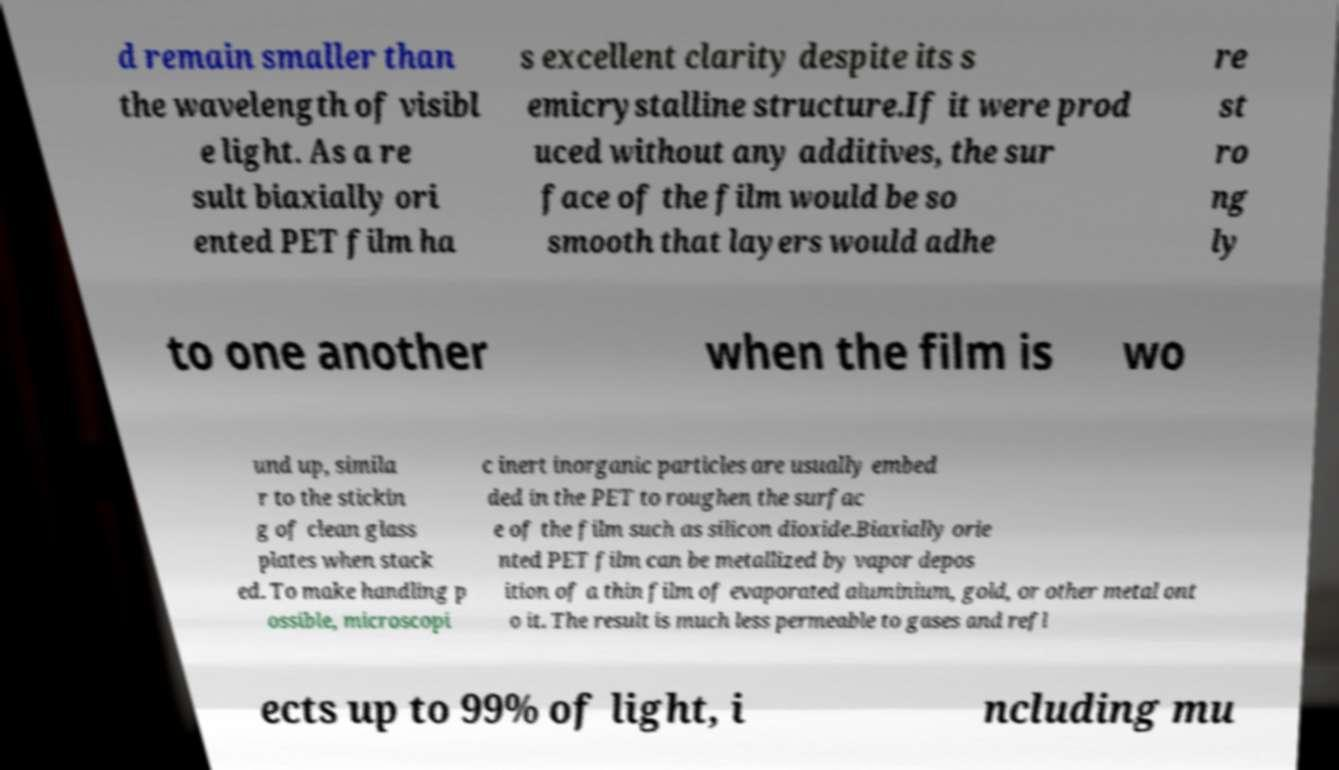Can you read and provide the text displayed in the image?This photo seems to have some interesting text. Can you extract and type it out for me? d remain smaller than the wavelength of visibl e light. As a re sult biaxially ori ented PET film ha s excellent clarity despite its s emicrystalline structure.If it were prod uced without any additives, the sur face of the film would be so smooth that layers would adhe re st ro ng ly to one another when the film is wo und up, simila r to the stickin g of clean glass plates when stack ed. To make handling p ossible, microscopi c inert inorganic particles are usually embed ded in the PET to roughen the surfac e of the film such as silicon dioxide.Biaxially orie nted PET film can be metallized by vapor depos ition of a thin film of evaporated aluminium, gold, or other metal ont o it. The result is much less permeable to gases and refl ects up to 99% of light, i ncluding mu 